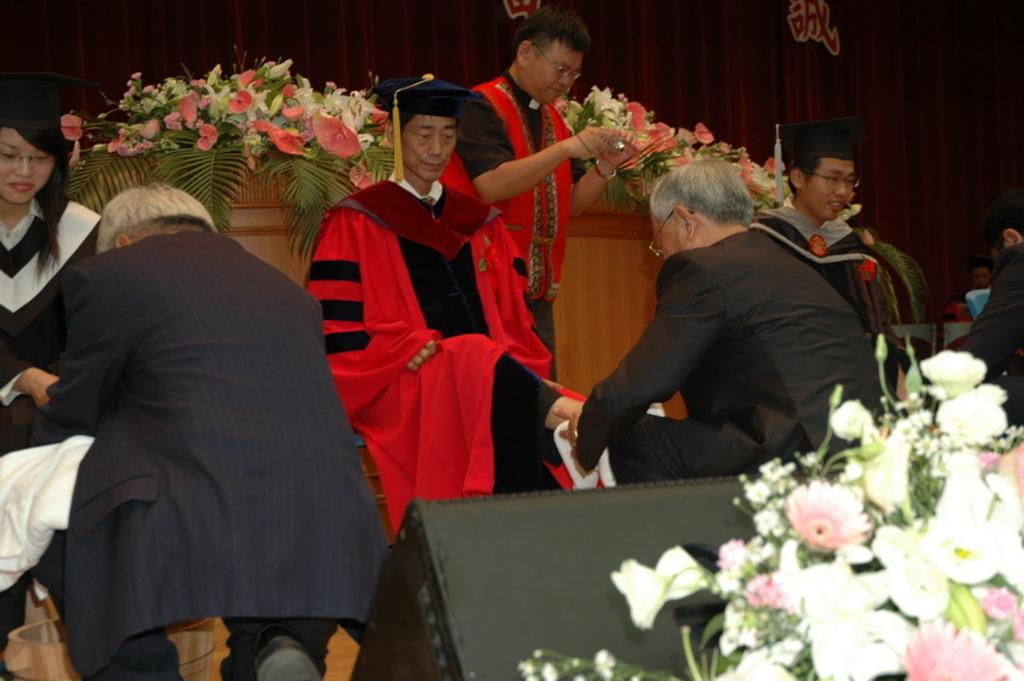How many people are sitting in the image? There are three persons sitting in the image. What are the sitting persons wearing on their heads? The sitting persons are wearing caps. Is there anyone standing in the image? Yes, there is a person standing in the image. What can be seen in the image besides the persons? There are flower bouquets in the image. What is visible in the background of the image? There is a curtain in the background of the image. Can you see a squirrel playing in the dirt in the image? No, there is no squirrel or dirt present in the image. Who is the friend of the person standing in the image? The provided facts do not mention any friends or relationships between the persons in the image. 